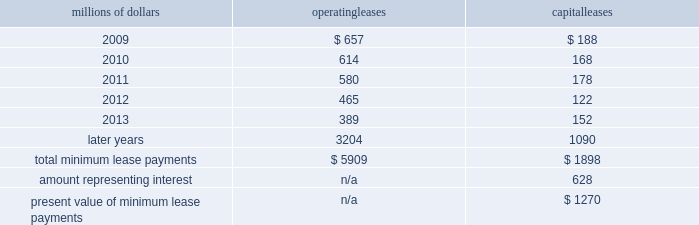14 .
Leases we lease certain locomotives , freight cars , and other property .
The consolidated statement of financial position as of december 31 , 2008 and 2007 included $ 2024 million , net of $ 869 million of amortization , and $ 2062 million , net of $ 887 million of amortization , respectively , for properties held under capital leases .
A charge to income resulting from the amortization for assets held under capital leases is included within depreciation expense in our consolidated statements of income .
Future minimum lease payments for operating and capital leases with initial or remaining non-cancelable lease terms in excess of one year as of december 31 , 2008 were as follows : millions of dollars operating leases capital leases .
The majority of capital lease payments relate to locomotives .
Rent expense for operating leases with terms exceeding one month was $ 747 million in 2008 , $ 810 million in 2007 , and $ 798 million in 2006 .
When cash rental payments are not made on a straight-line basis , we recognize variable rental expense on a straight-line basis over the lease term .
Contingent rentals and sub-rentals are not significant .
15 .
Commitments and contingencies asserted and unasserted claims 2013 various claims and lawsuits are pending against us and certain of our subsidiaries .
We cannot fully determine the effect of all asserted and unasserted claims on our consolidated results of operations , financial condition , or liquidity ; however , to the extent possible , where asserted and unasserted claims are considered probable and where such claims can be reasonably estimated , we have recorded a liability .
We do not expect that any known lawsuits , claims , environmental costs , commitments , contingent liabilities , or guarantees will have a material adverse effect on our consolidated results of operations , financial condition , or liquidity after taking into account liabilities and insurance recoveries previously recorded for these matters .
Personal injury 2013 the cost of personal injuries to employees and others related to our activities is charged to expense based on estimates of the ultimate cost and number of incidents each year .
We use third-party actuaries to assist us in measuring the expense and liability , including unasserted claims .
The federal employers 2019 liability act ( fela ) governs compensation for work-related accidents .
Under fela , damages are assessed based on a finding of fault through litigation or out-of-court settlements .
We offer a comprehensive variety of services and rehabilitation programs for employees who are injured at our personal injury liability is discounted to present value using applicable u.s .
Treasury rates .
Approximately 88% ( 88 % ) of the recorded liability related to asserted claims , and approximately 12% ( 12 % ) related to unasserted claims at december 31 , 2008 .
Because of the uncertainty surrounding the ultimate outcome of personal injury claims , it is reasonably possible that future costs to settle these claims may range from .
What was the ratio of the rent expense for operating leases with terms exceeding one month in 2008 to 2007? 
Computations: (747 / 810)
Answer: 0.92222. 